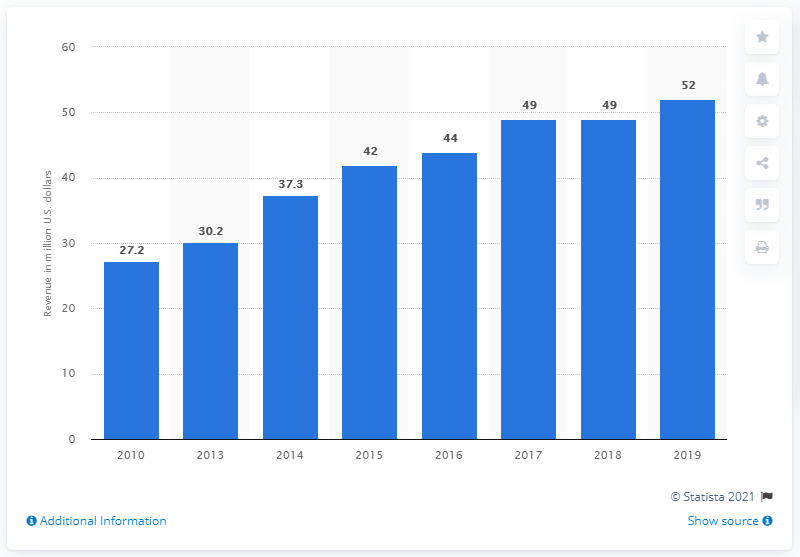Outline some significant characteristics in this image. In 2019, the Golden Globes generated $52 million in revenue. 